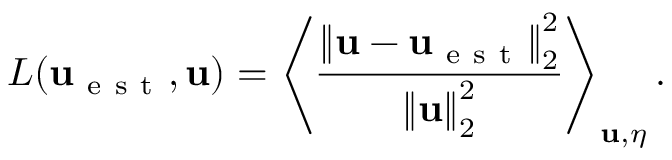<formula> <loc_0><loc_0><loc_500><loc_500>L ( u _ { e s t } , u ) = \left \langle \frac { \left \| u - u _ { e s t } \right \| _ { 2 } ^ { 2 } } { \left \| u \right \| _ { 2 } ^ { 2 } } \right \rangle _ { u , \eta } .</formula> 